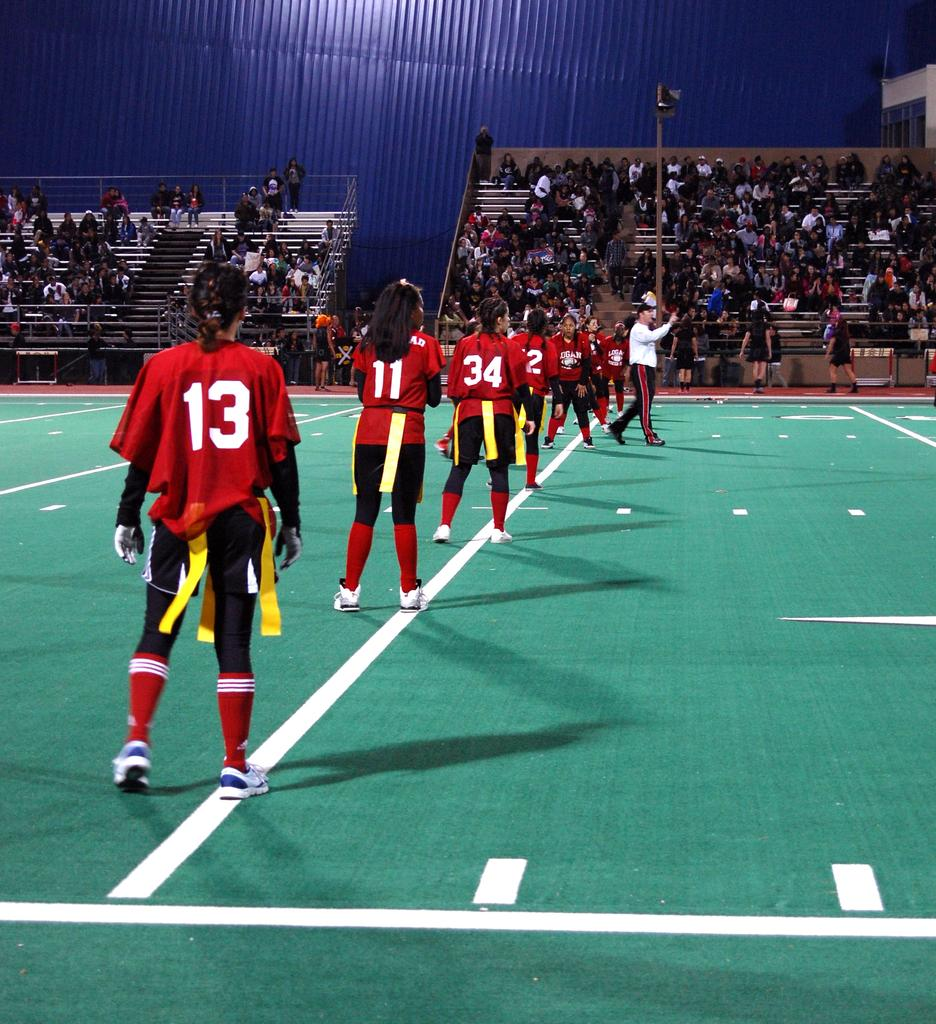What is happening with the people in the image? There are people on the ground in the image, but their specific activity is not clear. What can be seen in the background of the image? In the background of the image, there is an audience, a pole, railings, and a blue sheet. Can you describe the audience in the image? The audience is visible in the background, but their specific actions or expressions are not clear. What type of structure might the pole and railings be part of? The pole and railings in the background could be part of a stadium, amphitheater, or other public gathering space. What type of knife is being used to cut the nest in the image? There is no knife or nest present in the image. 